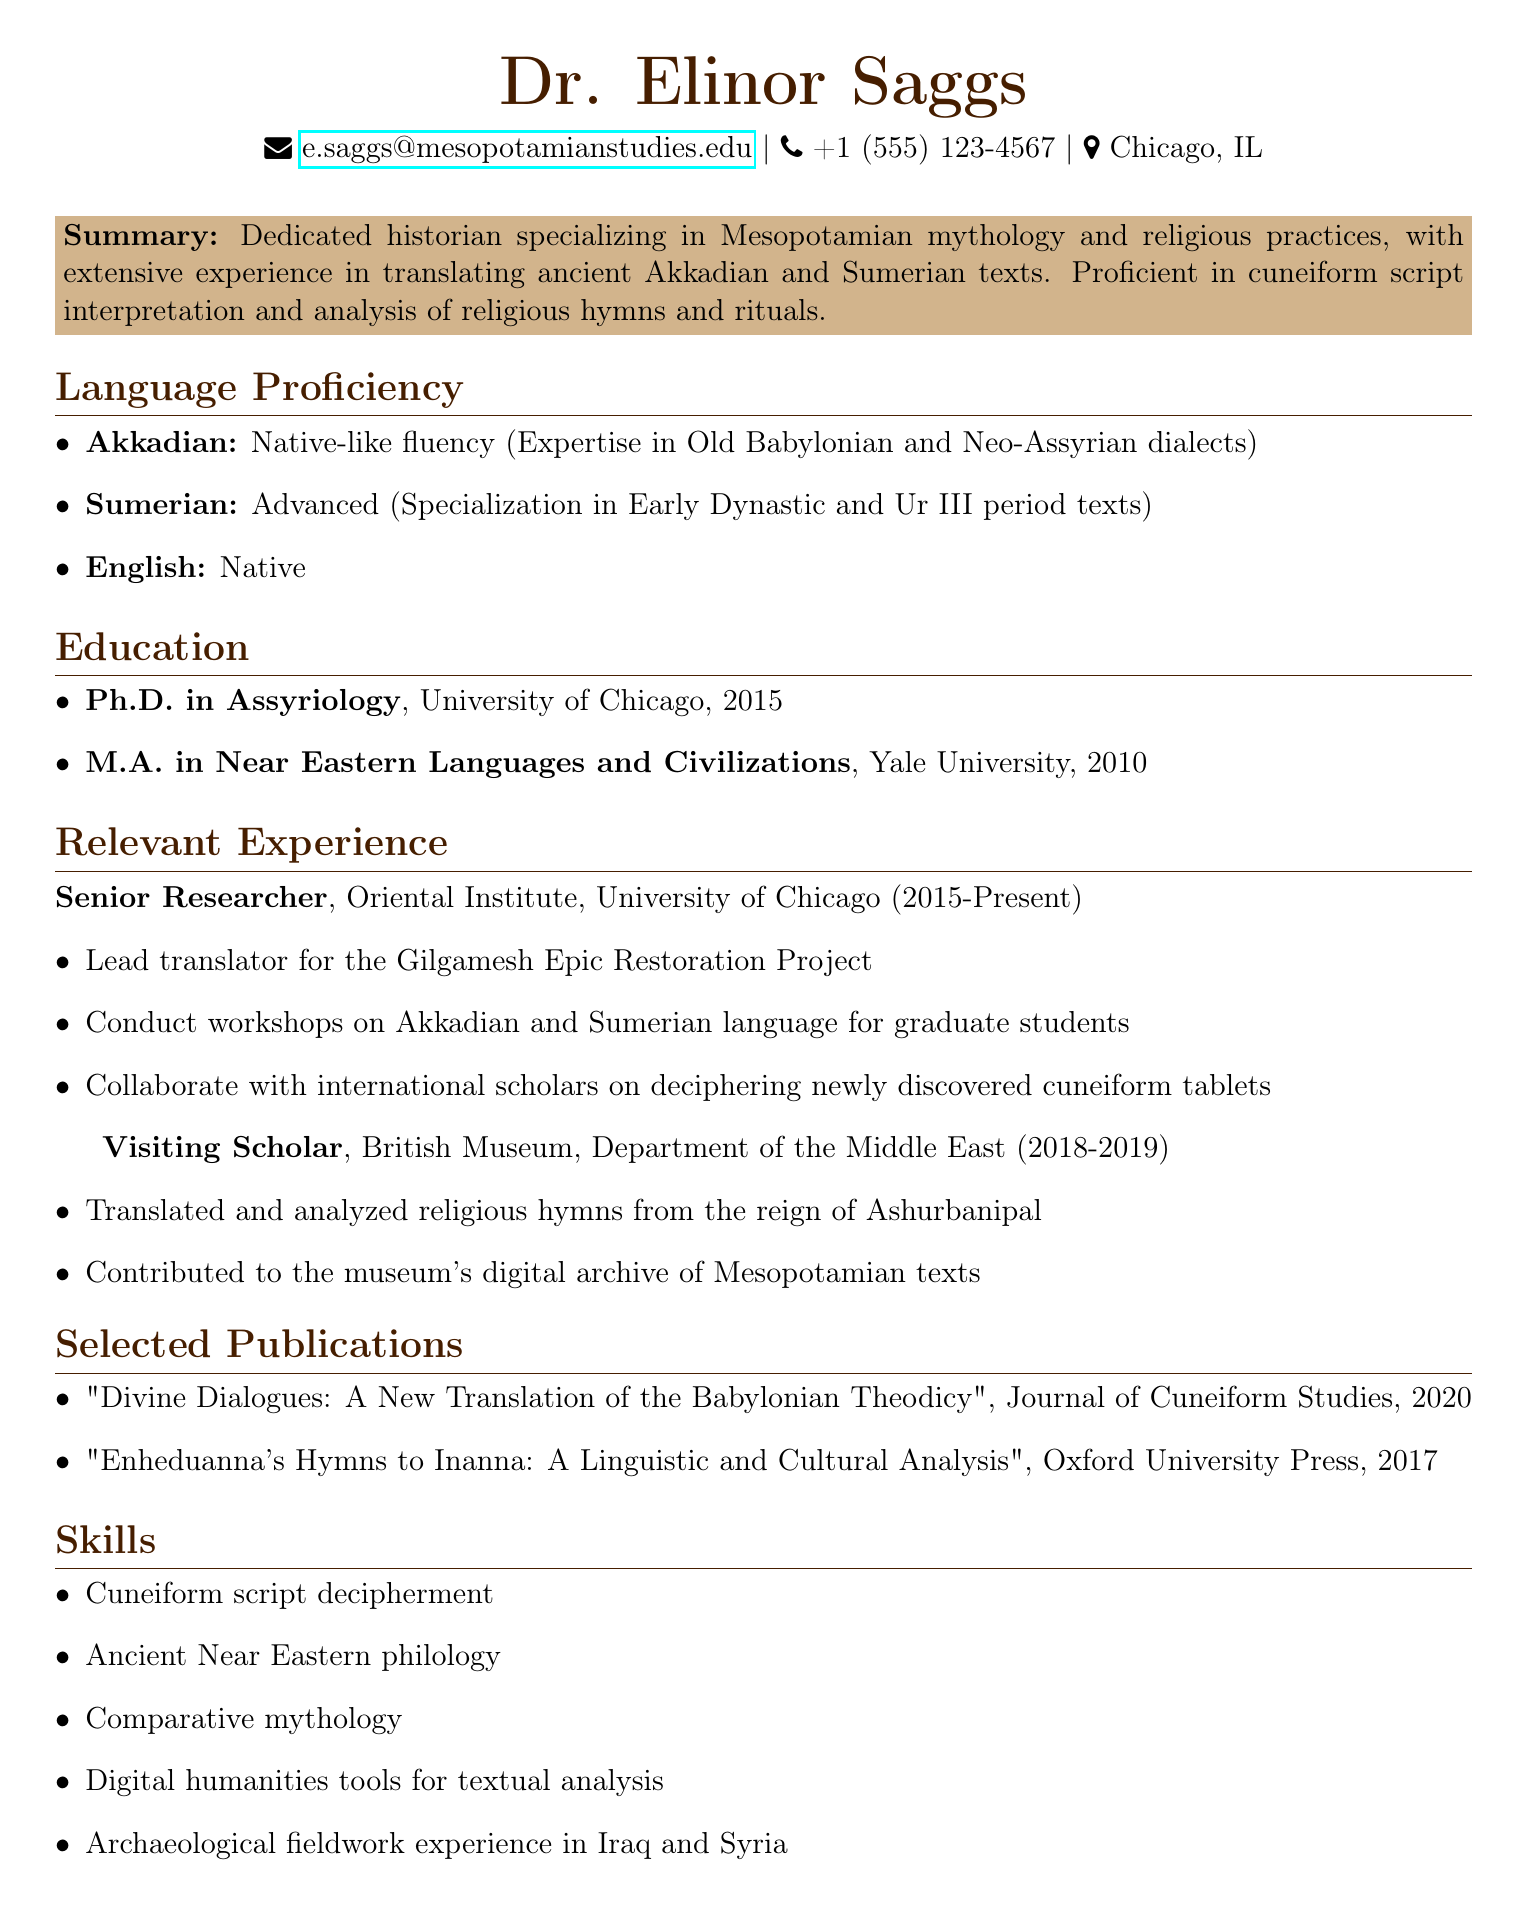What is the name of the individual? The document provides the name of the individual at the top, "Dr. Elinor Saggs."
Answer: Dr. Elinor Saggs What is the email address listed? The email address is stated in the personal information section of the document.
Answer: e.saggs@mesopotamianstudies.edu In which year did Dr. Saggs receive their Ph.D.? The year of the Ph.D. degree is specified in the education section.
Answer: 2015 What institution did Dr. Saggs attend for their Master's degree? The institution where Dr. Saggs completed their M.A. is detailed in the education section.
Answer: Yale University What is Dr. Saggs's level of proficiency in Sumerian? The document indicates the proficiency level of Sumerian in the language proficiency section.
Answer: Advanced What project is Dr. Saggs the lead translator for? The relevant experience section notes the project they lead.
Answer: Gilgamesh Epic Restoration Project What type of analysis did Dr. Saggs conduct for the British Museum? The document describes the type of work done while at the British Museum.
Answer: Translated and analyzed religious hymns Which publication was released in 2020? The year of publication is provided next to the titles in the publications section.
Answer: "Divine Dialogues: A New Translation of the Babylonian Theodicy" How many skills are listed in the skills section? The number of skills is counted based on the list provided in the skills section.
Answer: Five 